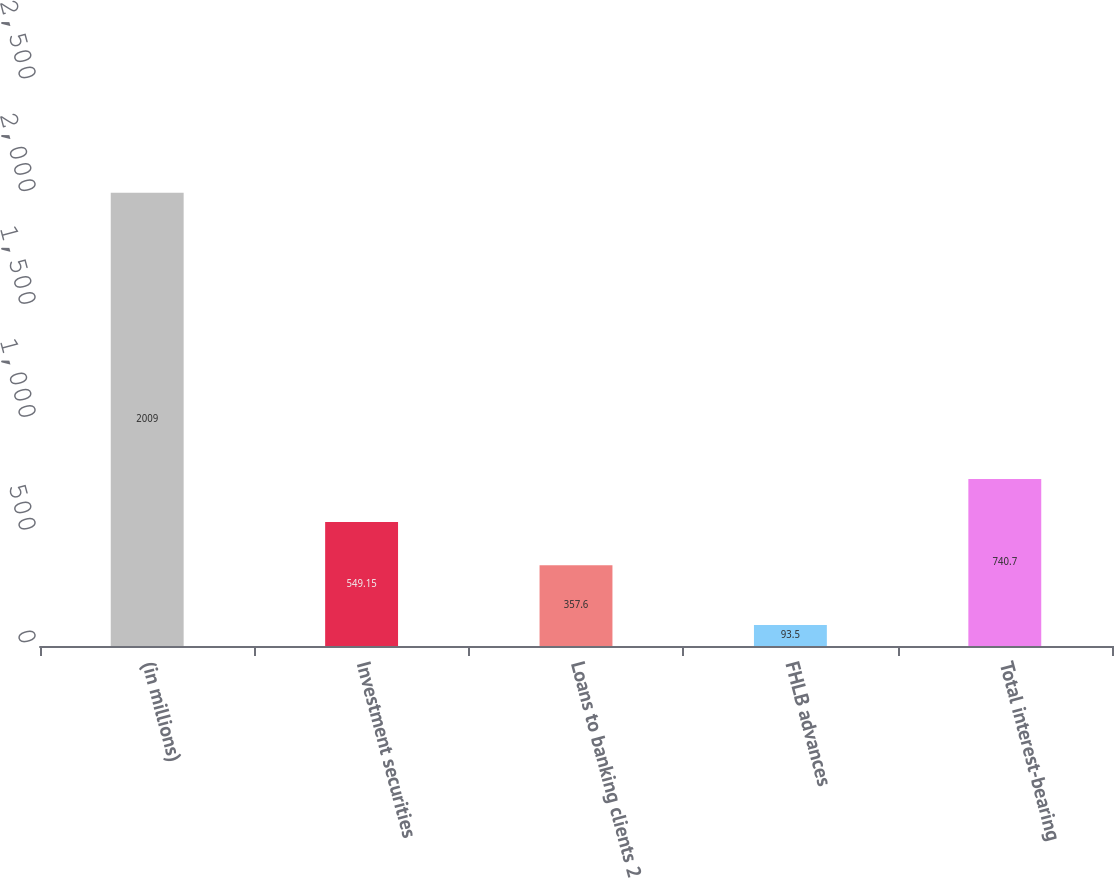Convert chart. <chart><loc_0><loc_0><loc_500><loc_500><bar_chart><fcel>(in millions)<fcel>Investment securities<fcel>Loans to banking clients 2<fcel>FHLB advances<fcel>Total interest-bearing<nl><fcel>2009<fcel>549.15<fcel>357.6<fcel>93.5<fcel>740.7<nl></chart> 